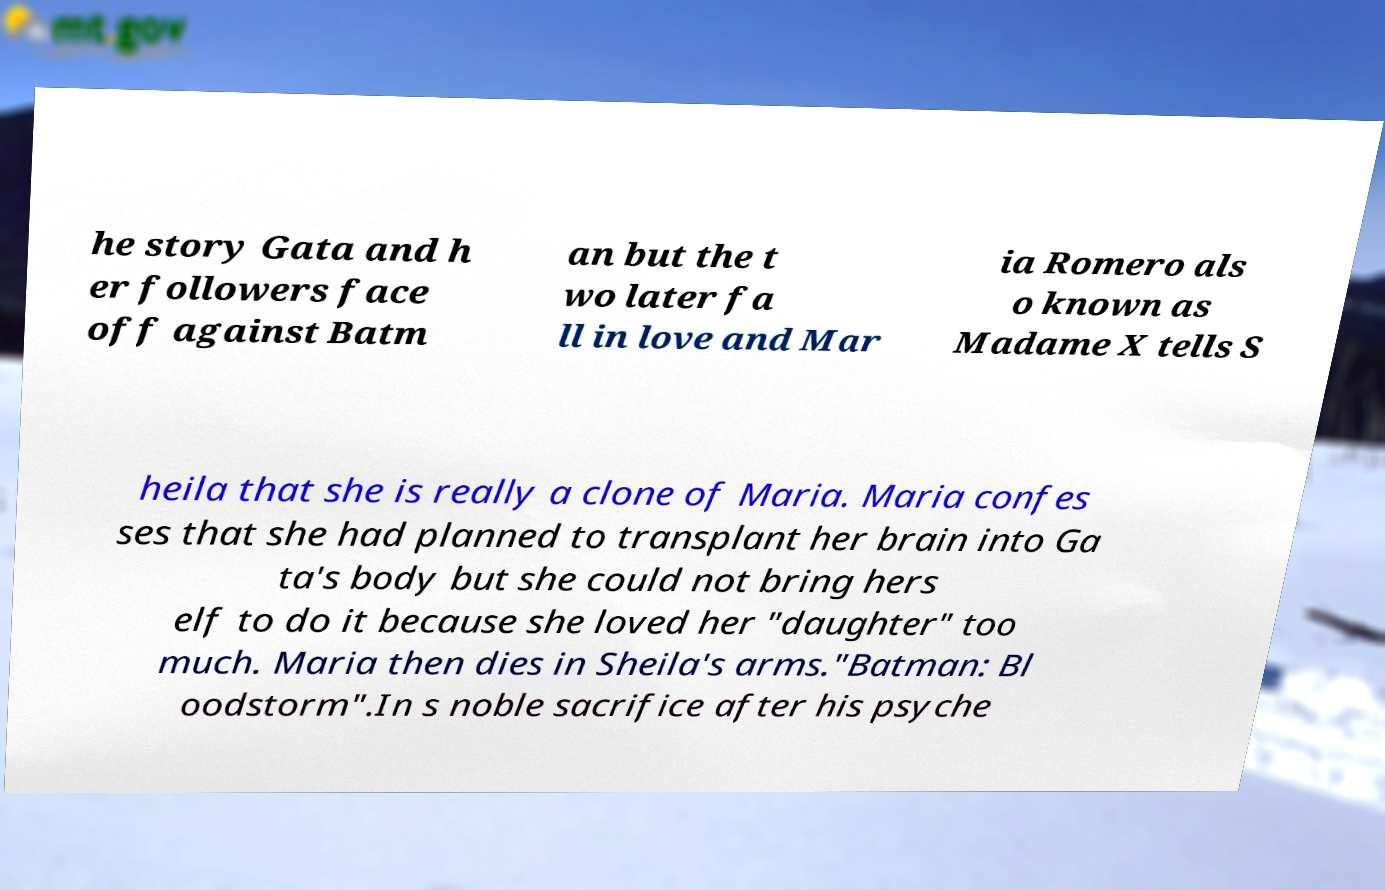Please read and relay the text visible in this image. What does it say? he story Gata and h er followers face off against Batm an but the t wo later fa ll in love and Mar ia Romero als o known as Madame X tells S heila that she is really a clone of Maria. Maria confes ses that she had planned to transplant her brain into Ga ta's body but she could not bring hers elf to do it because she loved her "daughter" too much. Maria then dies in Sheila's arms."Batman: Bl oodstorm".In s noble sacrifice after his psyche 